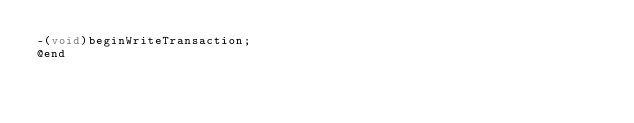<code> <loc_0><loc_0><loc_500><loc_500><_C_>-(void)beginWriteTransaction;
@end

</code> 